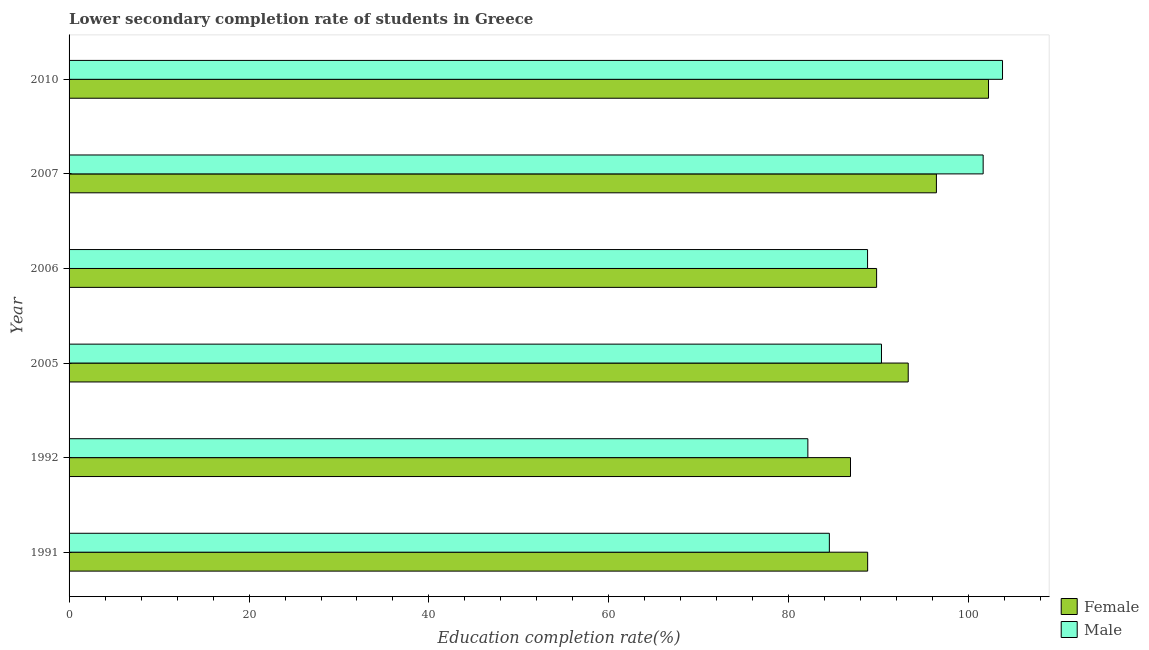How many different coloured bars are there?
Offer a terse response. 2. How many groups of bars are there?
Provide a short and direct response. 6. Are the number of bars on each tick of the Y-axis equal?
Provide a succinct answer. Yes. How many bars are there on the 6th tick from the top?
Keep it short and to the point. 2. What is the label of the 2nd group of bars from the top?
Your answer should be compact. 2007. In how many cases, is the number of bars for a given year not equal to the number of legend labels?
Keep it short and to the point. 0. What is the education completion rate of male students in 2010?
Offer a very short reply. 103.75. Across all years, what is the maximum education completion rate of male students?
Keep it short and to the point. 103.75. Across all years, what is the minimum education completion rate of male students?
Provide a short and direct response. 82.11. In which year was the education completion rate of female students maximum?
Give a very brief answer. 2010. What is the total education completion rate of male students in the graph?
Provide a succinct answer. 551. What is the difference between the education completion rate of male students in 1992 and that in 2010?
Give a very brief answer. -21.64. What is the difference between the education completion rate of female students in 2007 and the education completion rate of male students in 2010?
Offer a very short reply. -7.35. What is the average education completion rate of male students per year?
Your answer should be compact. 91.83. Is the education completion rate of female students in 1992 less than that in 2007?
Ensure brevity in your answer.  Yes. What is the difference between the highest and the second highest education completion rate of female students?
Provide a succinct answer. 5.79. What is the difference between the highest and the lowest education completion rate of male students?
Make the answer very short. 21.64. Is the sum of the education completion rate of male students in 2005 and 2010 greater than the maximum education completion rate of female students across all years?
Provide a succinct answer. Yes. What does the 1st bar from the top in 2007 represents?
Your answer should be compact. Male. How many bars are there?
Give a very brief answer. 12. How many years are there in the graph?
Your response must be concise. 6. Does the graph contain any zero values?
Keep it short and to the point. No. How many legend labels are there?
Keep it short and to the point. 2. How are the legend labels stacked?
Ensure brevity in your answer.  Vertical. What is the title of the graph?
Offer a very short reply. Lower secondary completion rate of students in Greece. What is the label or title of the X-axis?
Your answer should be compact. Education completion rate(%). What is the label or title of the Y-axis?
Your answer should be very brief. Year. What is the Education completion rate(%) in Female in 1991?
Offer a terse response. 88.76. What is the Education completion rate(%) in Male in 1991?
Your response must be concise. 84.5. What is the Education completion rate(%) of Female in 1992?
Offer a terse response. 86.85. What is the Education completion rate(%) of Male in 1992?
Offer a very short reply. 82.11. What is the Education completion rate(%) in Female in 2005?
Offer a terse response. 93.27. What is the Education completion rate(%) of Male in 2005?
Offer a terse response. 90.3. What is the Education completion rate(%) in Female in 2006?
Your response must be concise. 89.75. What is the Education completion rate(%) of Male in 2006?
Ensure brevity in your answer.  88.75. What is the Education completion rate(%) of Female in 2007?
Keep it short and to the point. 96.4. What is the Education completion rate(%) in Male in 2007?
Give a very brief answer. 101.6. What is the Education completion rate(%) in Female in 2010?
Offer a very short reply. 102.19. What is the Education completion rate(%) in Male in 2010?
Offer a terse response. 103.75. Across all years, what is the maximum Education completion rate(%) in Female?
Offer a very short reply. 102.19. Across all years, what is the maximum Education completion rate(%) of Male?
Offer a very short reply. 103.75. Across all years, what is the minimum Education completion rate(%) in Female?
Make the answer very short. 86.85. Across all years, what is the minimum Education completion rate(%) of Male?
Your answer should be compact. 82.11. What is the total Education completion rate(%) of Female in the graph?
Offer a terse response. 557.22. What is the total Education completion rate(%) in Male in the graph?
Offer a terse response. 551. What is the difference between the Education completion rate(%) in Female in 1991 and that in 1992?
Make the answer very short. 1.91. What is the difference between the Education completion rate(%) in Male in 1991 and that in 1992?
Provide a short and direct response. 2.39. What is the difference between the Education completion rate(%) in Female in 1991 and that in 2005?
Your answer should be very brief. -4.51. What is the difference between the Education completion rate(%) in Male in 1991 and that in 2005?
Offer a terse response. -5.79. What is the difference between the Education completion rate(%) of Female in 1991 and that in 2006?
Provide a short and direct response. -0.99. What is the difference between the Education completion rate(%) in Male in 1991 and that in 2006?
Provide a succinct answer. -4.25. What is the difference between the Education completion rate(%) of Female in 1991 and that in 2007?
Give a very brief answer. -7.64. What is the difference between the Education completion rate(%) in Male in 1991 and that in 2007?
Make the answer very short. -17.09. What is the difference between the Education completion rate(%) of Female in 1991 and that in 2010?
Your response must be concise. -13.43. What is the difference between the Education completion rate(%) in Male in 1991 and that in 2010?
Offer a very short reply. -19.25. What is the difference between the Education completion rate(%) in Female in 1992 and that in 2005?
Keep it short and to the point. -6.42. What is the difference between the Education completion rate(%) in Male in 1992 and that in 2005?
Make the answer very short. -8.18. What is the difference between the Education completion rate(%) in Female in 1992 and that in 2006?
Provide a short and direct response. -2.9. What is the difference between the Education completion rate(%) of Male in 1992 and that in 2006?
Ensure brevity in your answer.  -6.64. What is the difference between the Education completion rate(%) in Female in 1992 and that in 2007?
Your response must be concise. -9.55. What is the difference between the Education completion rate(%) in Male in 1992 and that in 2007?
Provide a short and direct response. -19.48. What is the difference between the Education completion rate(%) of Female in 1992 and that in 2010?
Provide a succinct answer. -15.34. What is the difference between the Education completion rate(%) in Male in 1992 and that in 2010?
Give a very brief answer. -21.64. What is the difference between the Education completion rate(%) in Female in 2005 and that in 2006?
Provide a short and direct response. 3.51. What is the difference between the Education completion rate(%) of Male in 2005 and that in 2006?
Your answer should be very brief. 1.55. What is the difference between the Education completion rate(%) in Female in 2005 and that in 2007?
Offer a very short reply. -3.13. What is the difference between the Education completion rate(%) in Male in 2005 and that in 2007?
Offer a very short reply. -11.3. What is the difference between the Education completion rate(%) of Female in 2005 and that in 2010?
Keep it short and to the point. -8.92. What is the difference between the Education completion rate(%) in Male in 2005 and that in 2010?
Ensure brevity in your answer.  -13.45. What is the difference between the Education completion rate(%) in Female in 2006 and that in 2007?
Give a very brief answer. -6.65. What is the difference between the Education completion rate(%) of Male in 2006 and that in 2007?
Keep it short and to the point. -12.85. What is the difference between the Education completion rate(%) in Female in 2006 and that in 2010?
Offer a terse response. -12.44. What is the difference between the Education completion rate(%) in Male in 2006 and that in 2010?
Provide a short and direct response. -15. What is the difference between the Education completion rate(%) of Female in 2007 and that in 2010?
Keep it short and to the point. -5.79. What is the difference between the Education completion rate(%) in Male in 2007 and that in 2010?
Provide a succinct answer. -2.15. What is the difference between the Education completion rate(%) in Female in 1991 and the Education completion rate(%) in Male in 1992?
Provide a succinct answer. 6.65. What is the difference between the Education completion rate(%) of Female in 1991 and the Education completion rate(%) of Male in 2005?
Offer a very short reply. -1.54. What is the difference between the Education completion rate(%) of Female in 1991 and the Education completion rate(%) of Male in 2006?
Provide a succinct answer. 0.01. What is the difference between the Education completion rate(%) of Female in 1991 and the Education completion rate(%) of Male in 2007?
Your answer should be compact. -12.84. What is the difference between the Education completion rate(%) in Female in 1991 and the Education completion rate(%) in Male in 2010?
Give a very brief answer. -14.99. What is the difference between the Education completion rate(%) of Female in 1992 and the Education completion rate(%) of Male in 2005?
Give a very brief answer. -3.44. What is the difference between the Education completion rate(%) in Female in 1992 and the Education completion rate(%) in Male in 2006?
Provide a short and direct response. -1.9. What is the difference between the Education completion rate(%) of Female in 1992 and the Education completion rate(%) of Male in 2007?
Make the answer very short. -14.75. What is the difference between the Education completion rate(%) in Female in 1992 and the Education completion rate(%) in Male in 2010?
Provide a succinct answer. -16.9. What is the difference between the Education completion rate(%) of Female in 2005 and the Education completion rate(%) of Male in 2006?
Make the answer very short. 4.52. What is the difference between the Education completion rate(%) in Female in 2005 and the Education completion rate(%) in Male in 2007?
Offer a terse response. -8.33. What is the difference between the Education completion rate(%) of Female in 2005 and the Education completion rate(%) of Male in 2010?
Your answer should be very brief. -10.48. What is the difference between the Education completion rate(%) of Female in 2006 and the Education completion rate(%) of Male in 2007?
Your answer should be compact. -11.84. What is the difference between the Education completion rate(%) in Female in 2006 and the Education completion rate(%) in Male in 2010?
Offer a very short reply. -13.99. What is the difference between the Education completion rate(%) in Female in 2007 and the Education completion rate(%) in Male in 2010?
Ensure brevity in your answer.  -7.35. What is the average Education completion rate(%) in Female per year?
Ensure brevity in your answer.  92.87. What is the average Education completion rate(%) of Male per year?
Keep it short and to the point. 91.83. In the year 1991, what is the difference between the Education completion rate(%) of Female and Education completion rate(%) of Male?
Offer a terse response. 4.26. In the year 1992, what is the difference between the Education completion rate(%) in Female and Education completion rate(%) in Male?
Offer a terse response. 4.74. In the year 2005, what is the difference between the Education completion rate(%) of Female and Education completion rate(%) of Male?
Ensure brevity in your answer.  2.97. In the year 2006, what is the difference between the Education completion rate(%) of Female and Education completion rate(%) of Male?
Provide a succinct answer. 1.01. In the year 2007, what is the difference between the Education completion rate(%) of Female and Education completion rate(%) of Male?
Ensure brevity in your answer.  -5.2. In the year 2010, what is the difference between the Education completion rate(%) in Female and Education completion rate(%) in Male?
Keep it short and to the point. -1.56. What is the ratio of the Education completion rate(%) in Male in 1991 to that in 1992?
Offer a terse response. 1.03. What is the ratio of the Education completion rate(%) in Female in 1991 to that in 2005?
Your answer should be compact. 0.95. What is the ratio of the Education completion rate(%) of Male in 1991 to that in 2005?
Your answer should be very brief. 0.94. What is the ratio of the Education completion rate(%) in Female in 1991 to that in 2006?
Give a very brief answer. 0.99. What is the ratio of the Education completion rate(%) in Male in 1991 to that in 2006?
Your response must be concise. 0.95. What is the ratio of the Education completion rate(%) in Female in 1991 to that in 2007?
Provide a short and direct response. 0.92. What is the ratio of the Education completion rate(%) in Male in 1991 to that in 2007?
Keep it short and to the point. 0.83. What is the ratio of the Education completion rate(%) in Female in 1991 to that in 2010?
Provide a short and direct response. 0.87. What is the ratio of the Education completion rate(%) in Male in 1991 to that in 2010?
Keep it short and to the point. 0.81. What is the ratio of the Education completion rate(%) in Female in 1992 to that in 2005?
Offer a terse response. 0.93. What is the ratio of the Education completion rate(%) of Male in 1992 to that in 2005?
Make the answer very short. 0.91. What is the ratio of the Education completion rate(%) of Male in 1992 to that in 2006?
Keep it short and to the point. 0.93. What is the ratio of the Education completion rate(%) in Female in 1992 to that in 2007?
Ensure brevity in your answer.  0.9. What is the ratio of the Education completion rate(%) in Male in 1992 to that in 2007?
Ensure brevity in your answer.  0.81. What is the ratio of the Education completion rate(%) in Female in 1992 to that in 2010?
Your response must be concise. 0.85. What is the ratio of the Education completion rate(%) in Male in 1992 to that in 2010?
Make the answer very short. 0.79. What is the ratio of the Education completion rate(%) in Female in 2005 to that in 2006?
Ensure brevity in your answer.  1.04. What is the ratio of the Education completion rate(%) of Male in 2005 to that in 2006?
Offer a terse response. 1.02. What is the ratio of the Education completion rate(%) in Female in 2005 to that in 2007?
Ensure brevity in your answer.  0.97. What is the ratio of the Education completion rate(%) of Male in 2005 to that in 2007?
Make the answer very short. 0.89. What is the ratio of the Education completion rate(%) in Female in 2005 to that in 2010?
Offer a very short reply. 0.91. What is the ratio of the Education completion rate(%) of Male in 2005 to that in 2010?
Offer a very short reply. 0.87. What is the ratio of the Education completion rate(%) in Female in 2006 to that in 2007?
Your answer should be very brief. 0.93. What is the ratio of the Education completion rate(%) in Male in 2006 to that in 2007?
Provide a short and direct response. 0.87. What is the ratio of the Education completion rate(%) in Female in 2006 to that in 2010?
Your answer should be very brief. 0.88. What is the ratio of the Education completion rate(%) of Male in 2006 to that in 2010?
Give a very brief answer. 0.86. What is the ratio of the Education completion rate(%) of Female in 2007 to that in 2010?
Provide a short and direct response. 0.94. What is the ratio of the Education completion rate(%) in Male in 2007 to that in 2010?
Provide a succinct answer. 0.98. What is the difference between the highest and the second highest Education completion rate(%) of Female?
Keep it short and to the point. 5.79. What is the difference between the highest and the second highest Education completion rate(%) in Male?
Ensure brevity in your answer.  2.15. What is the difference between the highest and the lowest Education completion rate(%) of Female?
Your response must be concise. 15.34. What is the difference between the highest and the lowest Education completion rate(%) of Male?
Your answer should be very brief. 21.64. 